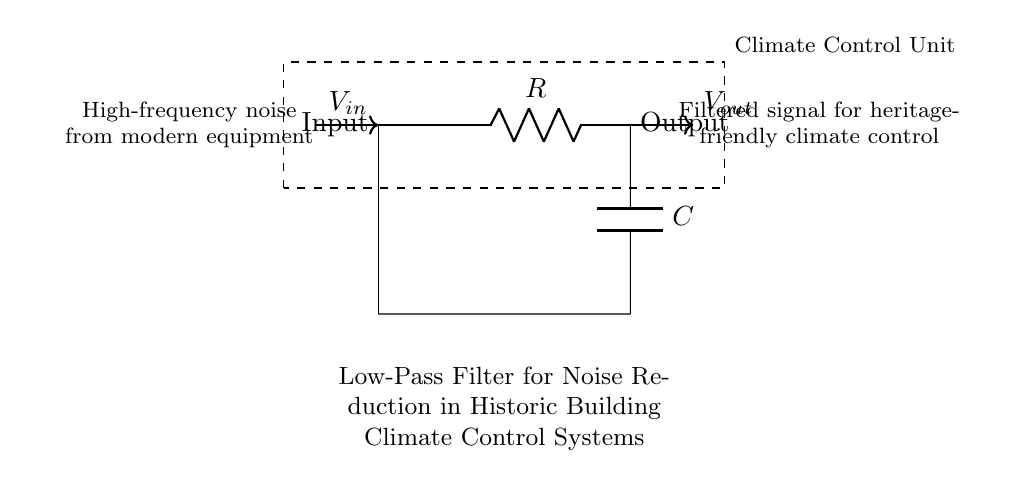What type of filter is represented in this circuit? The circuit clearly indicates that it is a low-pass filter, which allows low-frequency signals to pass while attenuating higher frequencies. This is confirmed by the presence of a resistor and a capacitor in series, connected to the input and output.
Answer: low-pass filter What components are used in this circuit? The circuit diagram features two main components: a resistor labeled R and a capacitor labeled C. These components are characteristic of a low-pass filter configuration and are connected to the climate control unit.
Answer: resistor and capacitor What is the function of the resistor in this circuit? In this low-pass filter, the resistor limits the amount of current flowing into the capacitor, helping to define the cutoff frequency of the filter. This interaction between the resistor and capacitor is crucial for filtering out high-frequency noise.
Answer: current limiting How does the capacitor influence the signal? The capacitor in this circuit stores energy and releases it according to the frequency of the incoming signal. It effectively allows low-frequency signals to pass while shunting high-frequency noise to ground, thus smoothing the output signal.
Answer: stores energy What is the purpose of this low-pass filter in historic building climate control systems? The primary purpose of this low-pass filter is to reduce high-frequency noise generated by modern climate control equipment, ensuring a more stable and heritage-friendly environment for maintaining historic buildings.
Answer: noise reduction What happens to high-frequency signals in this circuit? High-frequency signals are significantly attenuated or reduced by the interaction between the resistor and capacitor, which prevents these frequencies from appearing in the output signal. This helps in achieving a cleaner output for climate control applications.
Answer: attenuated What can be inferred about the climate control unit based on this circuit? The circuit indicates that the climate control unit receives an input signal that may contain high-frequency noise. The filtering action of the low-pass filter aims to provide a cleaner, low-frequency output signal, ensuring that the climate control system functions effectively without interference.
Answer: heritage-friendly operation 